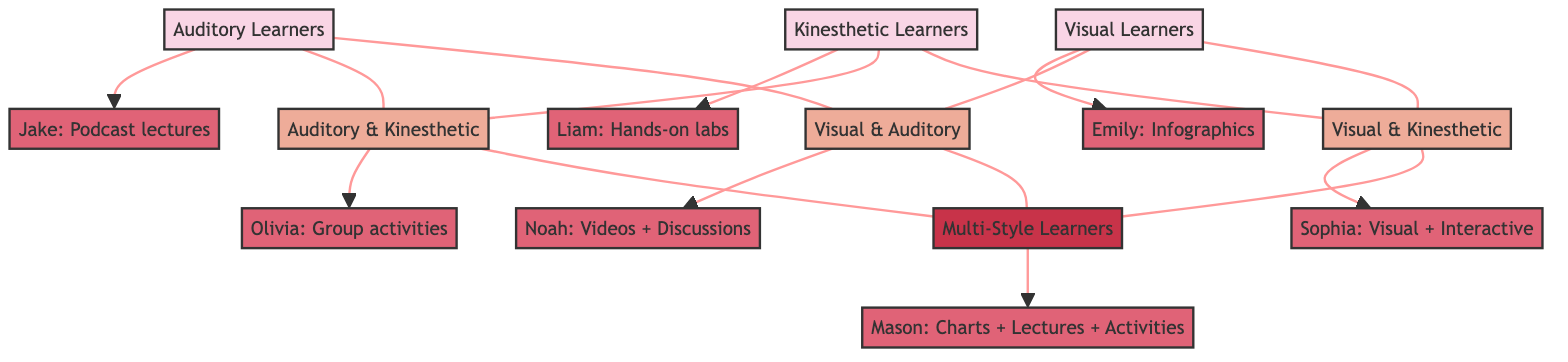What are the three primary learning styles represented in the diagram? The diagram clearly indicates three major learning styles labeled as Visual Learners, Auditory Learners, and Kinesthetic Learners. Each style is represented as a separate node in the structure.
Answer: Visual, Auditory, Kinesthetic How many secondary learning style combinations are shown in the diagram? By counting the secondary learning style combinations displayed, we have Visual & Kinesthetic, Visual & Auditory, and Auditory & Kinesthetic, which totals to three combinations.
Answer: 3 Which case study corresponds to Visual & Auditory learners? In the diagram, the node for Visual & Auditory learners leads to the case study of Noah, which outlines the method of using Videos + Discussions for this learning style.
Answer: Noah: Videos + Discussions What is the relationship between Kinesthetic Learners and Multi-Style Learners? The illustration shows a direct connecting line between Kinesthetic Learners and the Multi-Style Learners node, indicating that Kinesthetic Learners are included within those who can utilize multiple styles.
Answer: Direct connection Which student employs a teaching strategy tailored for Visual & Kinesthetic learners? The case study for Sophia demonstrates a strategy tailored for Visual + Interactive methods, which fits under the Visual & Kinesthetic learners' approach.
Answer: Sophia: Visual + Interactive How many total case studies are linked to learning styles in the diagram? By examining the diagram, we find seven distinct case studies connecting to various learning styles, providing a comprehensive overview of teaching strategies.
Answer: 7 What learning styles fall under the node labeled "ALL"? The "ALL" node represents Multi-Style Learners, which includes Visual, Auditory, Kinesthetic, Visual & Kinesthetic, Visual & Auditory, and Auditory & Kinesthetic learners.
Answer: Multi-Style Learners Which teaching strategy is linked to Auditory Learners? The diagram indicates that the case study linked to Auditory Learners is Jake, who employs Podcast lectures as his strategy.
Answer: Jake: Podcast lectures Which type of learners use Hands-on labs as a teaching strategy? The teaching strategy of Hands-on labs is applied to Kinesthetic Learners, as specified in the diagram.
Answer: Kinesthetic Learners 